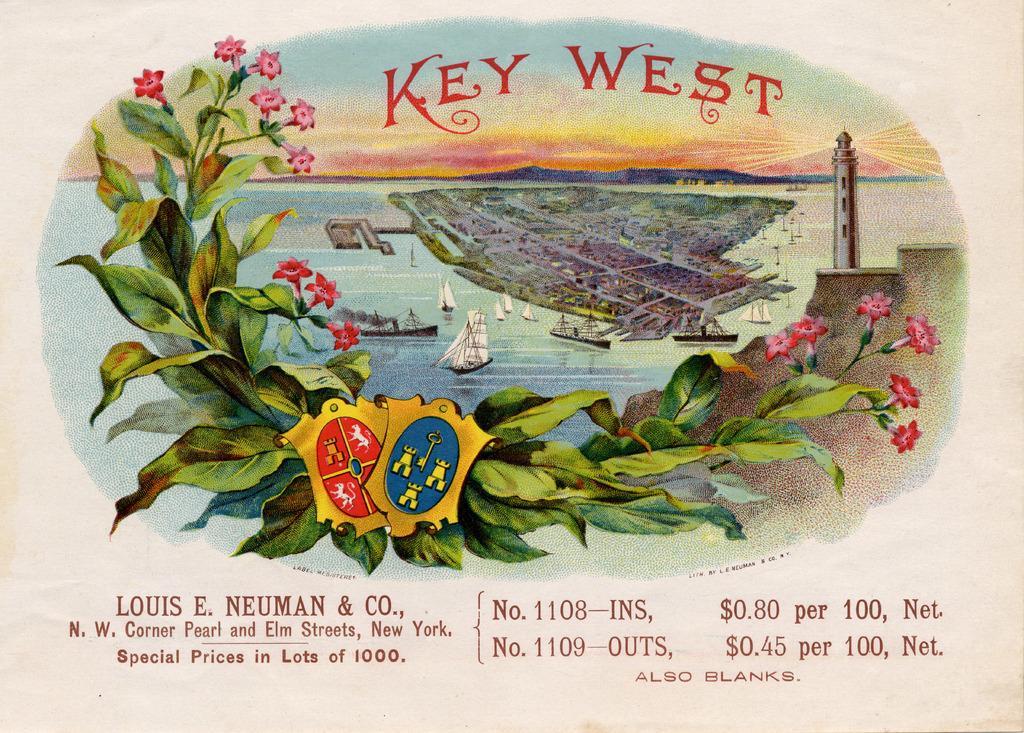How would you summarize this image in a sentence or two? In this picture I can see the leaves, flowers and 2 badges in front. In the background I can see the water on which there are boats and I see the sky. On the right side of this picture I see a light house and I see something is written on the bottom and top of this picture. I can also see that this is a depiction image. 